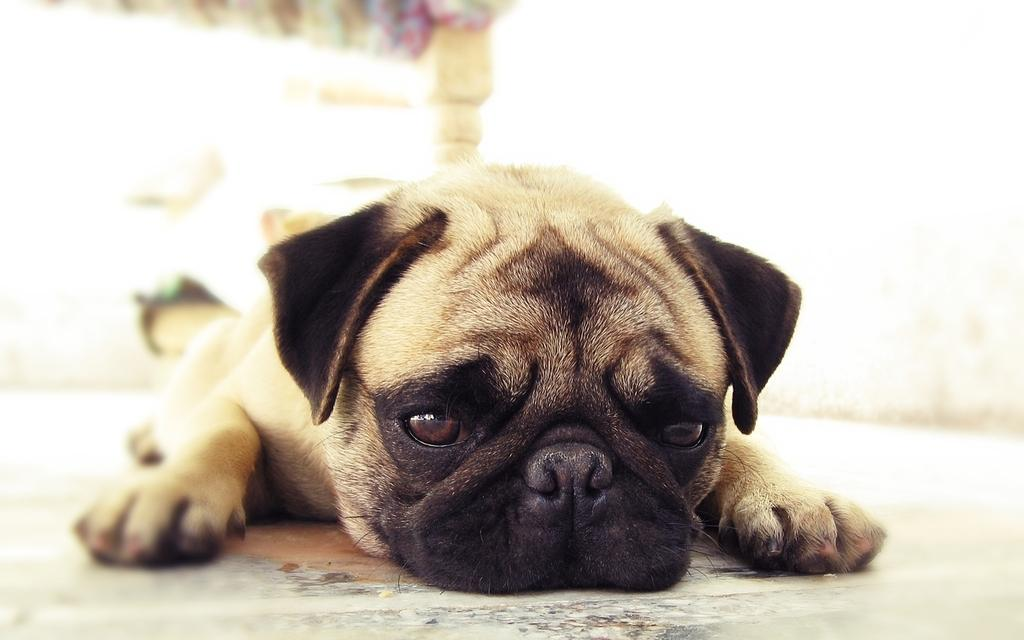What is the main subject of the image? There is a puppy in the image. What is the puppy doing in the image? The puppy is lying on a surface. Can you describe the background of the image? The background of the image is blurred. What type of jelly is the woman eating in the image? There is no woman or jelly present in the image; it features a puppy lying on a surface. 